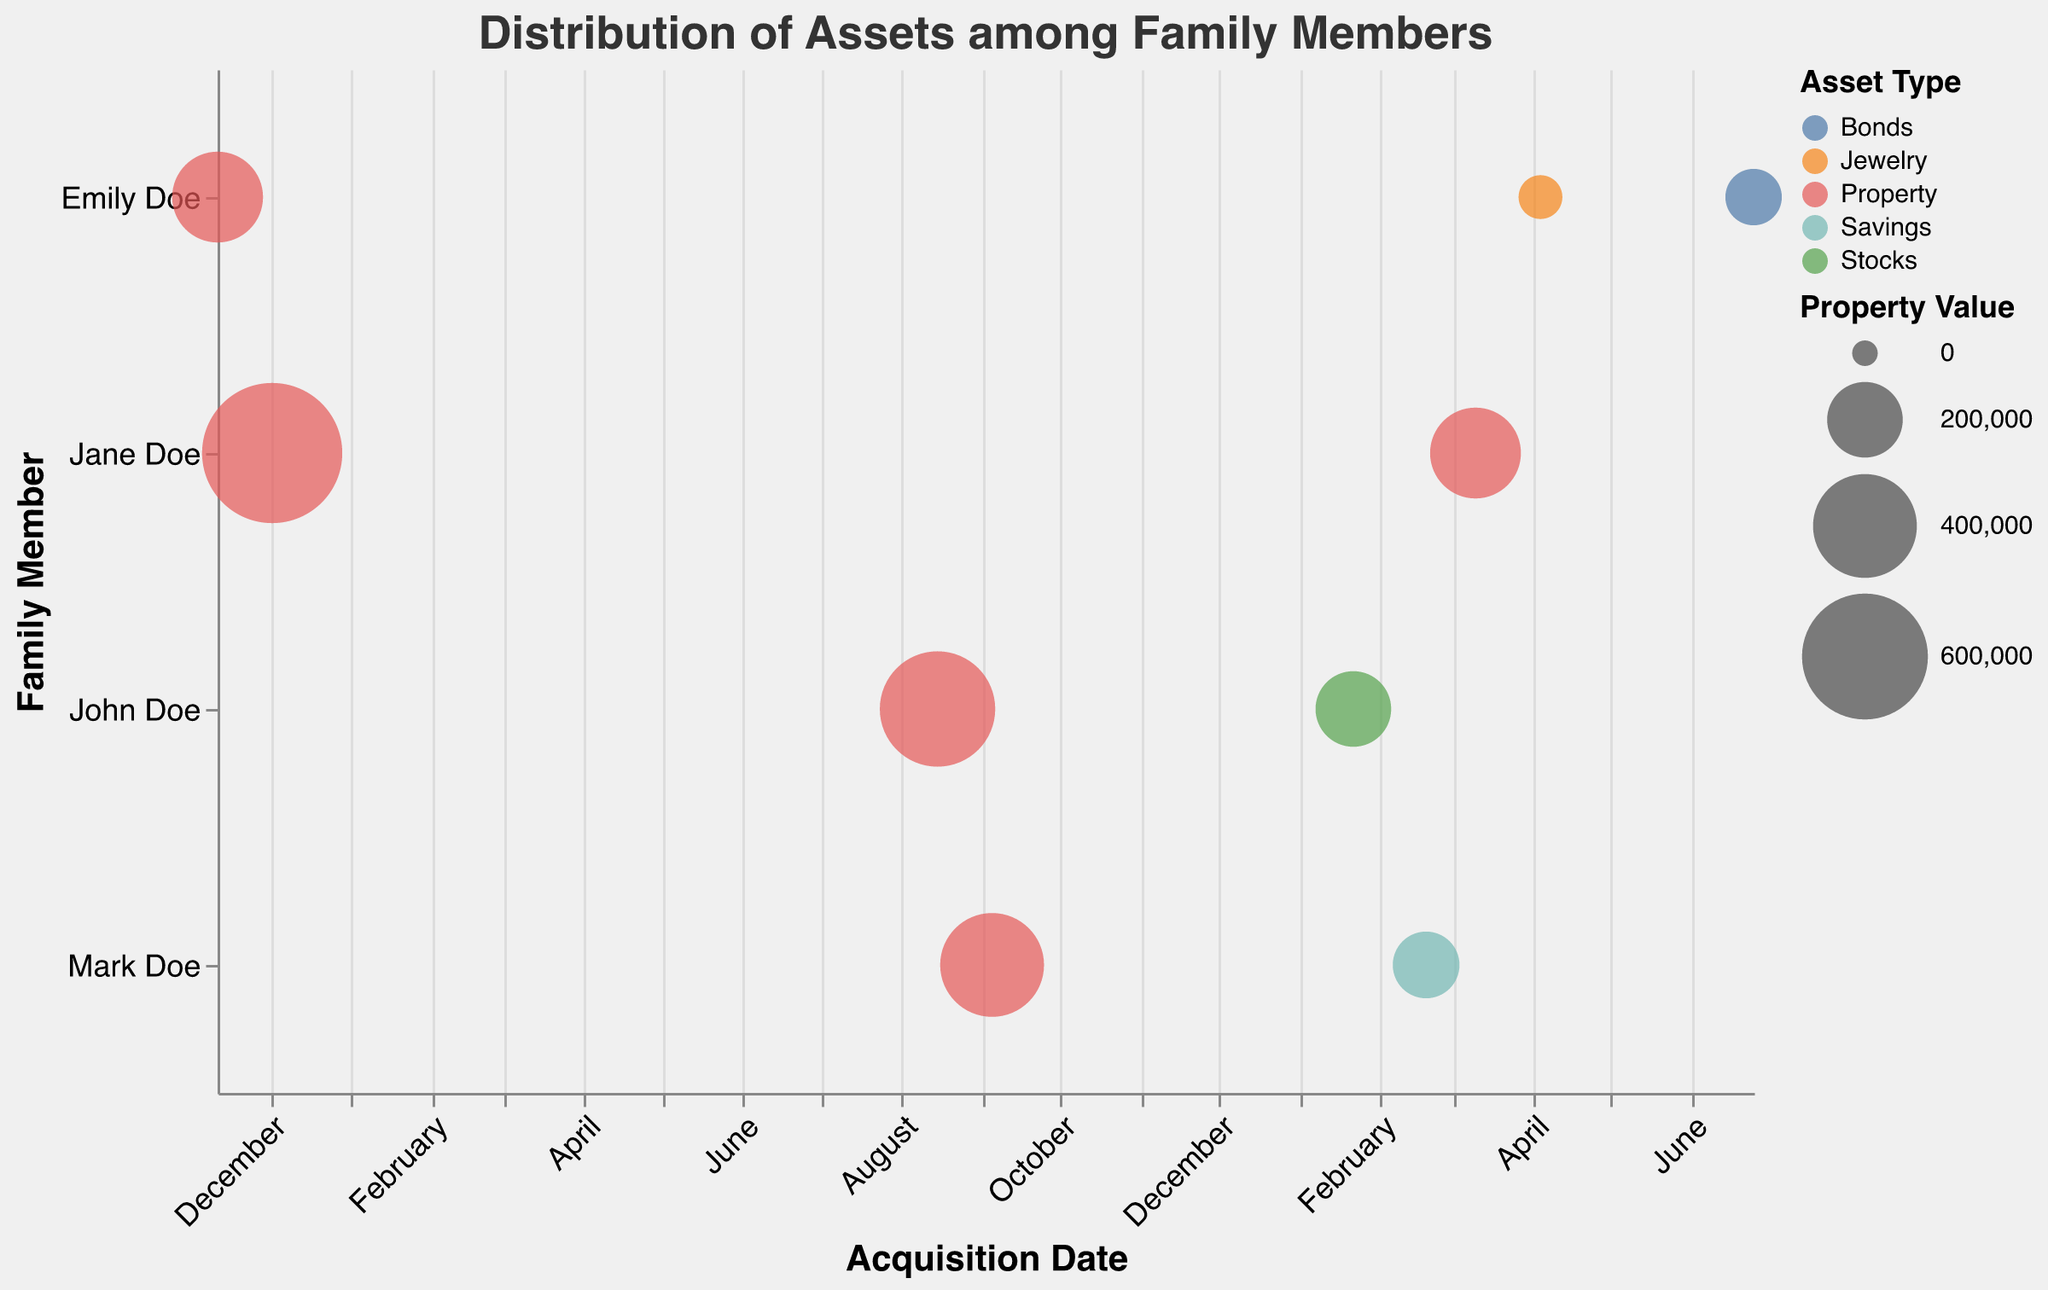What is the title of the bubble chart? The title of the chart is displayed at the top center and reads "Distribution of Assets among Family Members".
Answer: Distribution of Assets among Family Members Who owns the most valuable property and what is its value? The bubble with the largest size on the y-axis for "Jane Doe" indicates the most valuable property, valued at $750,000, specifically "456 Pine Avenue".
Answer: Jane Doe, $750,000 How many family members are included in the chart? The y-axis lists unique family members. Counting the different names, we have John Doe, Jane Doe, Mark Doe, and Emily Doe.
Answer: 4 Which asset type has the most recent acquisition date and who owns it? By looking at the x-axis for the most recent date and checking the corresponding bubble, "Bonds" held by Emily Doe was acquired on 2023-06-25.
Answer: Bonds, Emily Doe What is the value of the stock owned by John Doe and when was it acquired? For John Doe, the bubble colored for "Stocks" shows a value of $200,000, acquired on 2023-01-22.
Answer: $200,000, 2023-01-22 Which family member has the highest number of assets acquired in 2023? By identifying bubbles on the x-axis labeled with dates in 2023, and counting for each family member, Emily Doe has "Antique Necklace" and "Government Bonds" (2 assets), while John, Jane, and Mark each have 1 asset.
Answer: Emily Doe Compare the asset values between John Doe's property and Mark Doe's savings account. Which is higher? John Doe's property at "123 Oak Street" is valued at $500,000, and Mark Doe's savings account is valued at $150,000. Comparing these, John Doe's property value is higher.
Answer: John Doe's property What is the total value of properties acquired by Jane Doe? Jane Doe owns two properties acquired on 2021-12-02 and 2023-03-10. Summing their values: $750,000 + $300,000 = $1,050,000.
Answer: $1,050,000 Which asset by Emily Doe has the highest ownership percentage and what is that percentage? Checking Emily Doe's assets, the most recent acquisitions and highest ownership percentage show the "Antique Necklace" with 100%.
Answer: Antique Necklace, 100% What is the sum of property values owned by Mark Doe? Mark Doe owns "321 Birch Lane" property valued at $400,000. Since he does not own any other property, the sum remains $400,000.
Answer: $400,000 